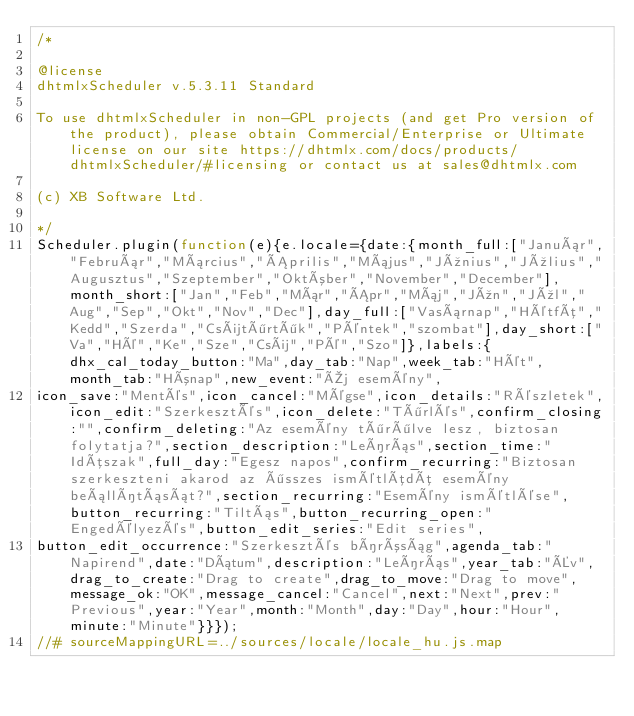Convert code to text. <code><loc_0><loc_0><loc_500><loc_500><_JavaScript_>/*

@license
dhtmlxScheduler v.5.3.11 Standard

To use dhtmlxScheduler in non-GPL projects (and get Pro version of the product), please obtain Commercial/Enterprise or Ultimate license on our site https://dhtmlx.com/docs/products/dhtmlxScheduler/#licensing or contact us at sales@dhtmlx.com

(c) XB Software Ltd.

*/
Scheduler.plugin(function(e){e.locale={date:{month_full:["Január","Február","Március","Április","Május","Június","Július","Augusztus","Szeptember","Október","November","December"],month_short:["Jan","Feb","Már","Ápr","Máj","Jún","Júl","Aug","Sep","Okt","Nov","Dec"],day_full:["Vasárnap","Hétfõ","Kedd","Szerda","Csütörtök","Péntek","szombat"],day_short:["Va","Hé","Ke","Sze","Csü","Pé","Szo"]},labels:{dhx_cal_today_button:"Ma",day_tab:"Nap",week_tab:"Hét",month_tab:"Hónap",new_event:"Új esemény",
icon_save:"Mentés",icon_cancel:"Mégse",icon_details:"Részletek",icon_edit:"Szerkesztés",icon_delete:"Törlés",confirm_closing:"",confirm_deleting:"Az esemény törölve lesz, biztosan folytatja?",section_description:"Leírás",section_time:"Idõszak",full_day:"Egesz napos",confirm_recurring:"Biztosan szerkeszteni akarod az összes ismétlõdõ esemény beállítását?",section_recurring:"Esemény ismétlése",button_recurring:"Tiltás",button_recurring_open:"Engedélyezés",button_edit_series:"Edit series",
button_edit_occurrence:"Szerkesztés bíróság",agenda_tab:"Napirend",date:"Dátum",description:"Leírás",year_tab:"Év",drag_to_create:"Drag to create",drag_to_move:"Drag to move",message_ok:"OK",message_cancel:"Cancel",next:"Next",prev:"Previous",year:"Year",month:"Month",day:"Day",hour:"Hour",minute:"Minute"}}});
//# sourceMappingURL=../sources/locale/locale_hu.js.map</code> 